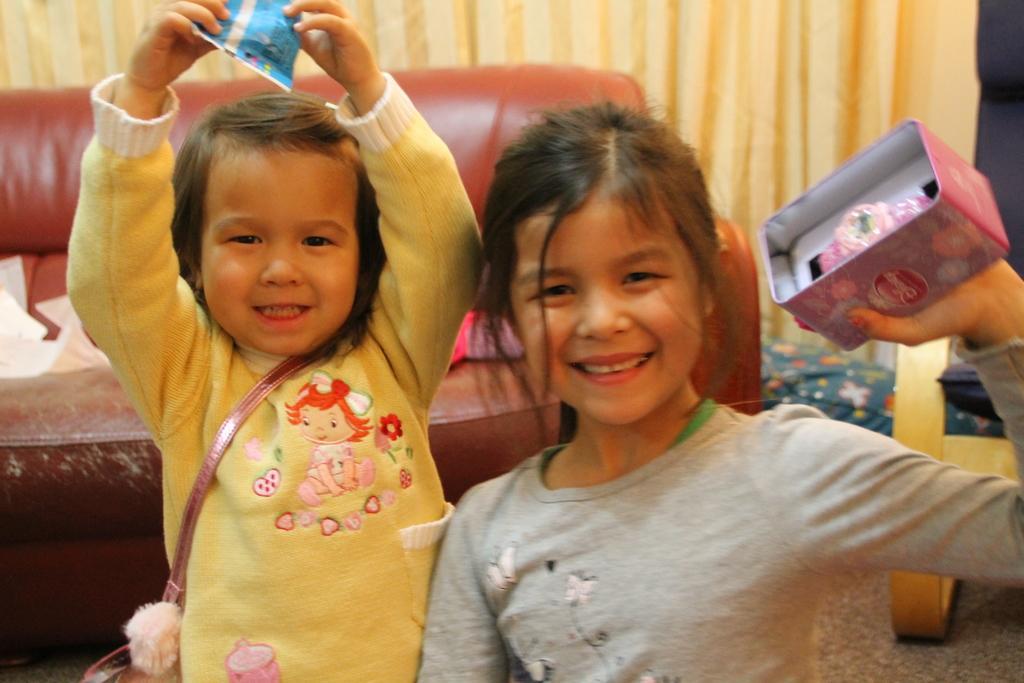Can you describe this image briefly? There is a baby in yellow color t-shirt, holding a blue color packet with both hands and smiling, near a girl who is in gray color t-shirt, holding a box and smiling. Back to them, there is a brown color sofa, on which, there are some objects, near a curtain and other objects. 